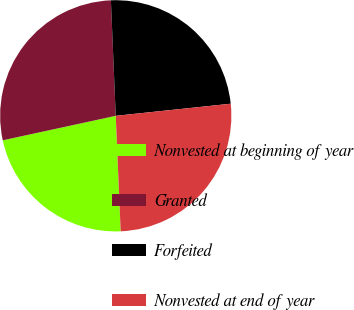<chart> <loc_0><loc_0><loc_500><loc_500><pie_chart><fcel>Nonvested at beginning of year<fcel>Granted<fcel>Forfeited<fcel>Nonvested at end of year<nl><fcel>22.28%<fcel>27.73%<fcel>24.0%<fcel>25.99%<nl></chart> 